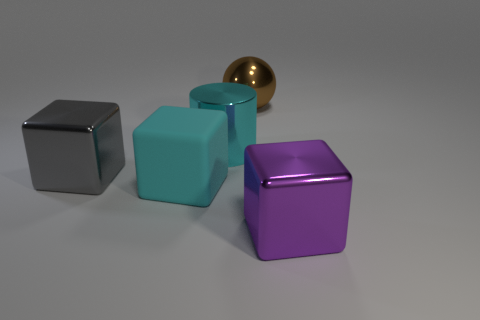What number of other objects are the same color as the big shiny sphere?
Offer a very short reply. 0. What number of objects are brown metallic spheres or cyan shiny cylinders?
Offer a terse response. 2. There is a cyan object in front of the gray shiny thing; is its shape the same as the large gray object?
Your response must be concise. Yes. There is a cube that is on the right side of the metallic object that is behind the large cyan metal cylinder; what color is it?
Offer a very short reply. Purple. Is the number of cyan shiny cylinders less than the number of green cylinders?
Provide a short and direct response. No. Are there any other large cubes that have the same material as the purple block?
Provide a succinct answer. Yes. There is a large purple thing; is it the same shape as the matte object that is in front of the cyan shiny object?
Your response must be concise. Yes. Are there any purple cubes behind the large brown metal ball?
Your response must be concise. No. How many other large shiny things are the same shape as the large brown thing?
Provide a succinct answer. 0. Is the cylinder made of the same material as the object that is on the right side of the large brown metallic ball?
Provide a succinct answer. Yes. 